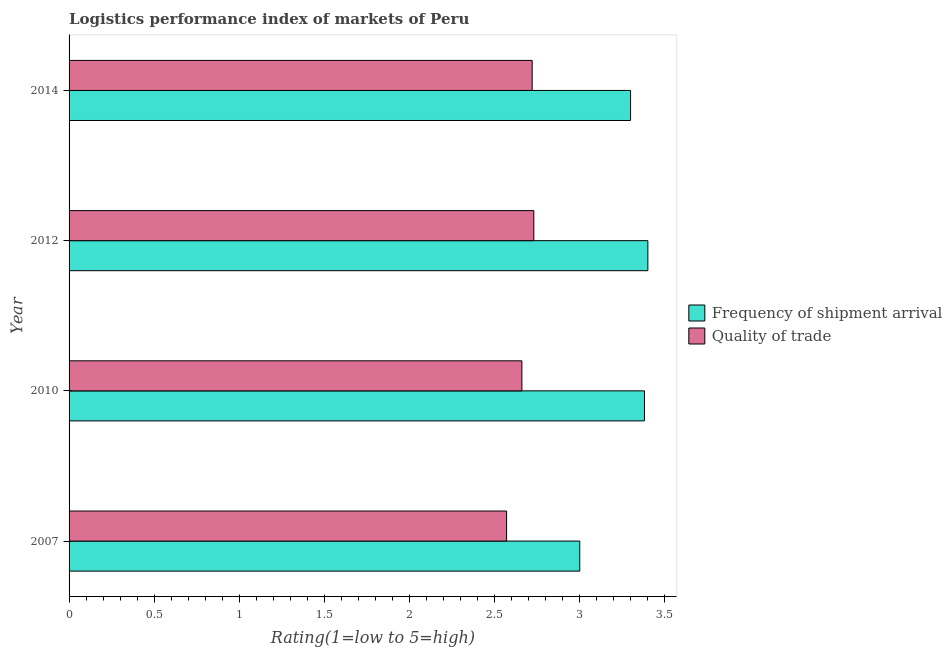What is the lpi quality of trade in 2007?
Provide a succinct answer. 2.57. What is the total lpi of frequency of shipment arrival in the graph?
Offer a terse response. 13.08. What is the difference between the lpi of frequency of shipment arrival in 2012 and that in 2014?
Provide a short and direct response. 0.1. What is the difference between the lpi of frequency of shipment arrival in 2010 and the lpi quality of trade in 2012?
Keep it short and to the point. 0.65. What is the average lpi of frequency of shipment arrival per year?
Your response must be concise. 3.27. In the year 2010, what is the difference between the lpi quality of trade and lpi of frequency of shipment arrival?
Make the answer very short. -0.72. In how many years, is the lpi quality of trade greater than 2.9 ?
Offer a terse response. 0. What is the ratio of the lpi of frequency of shipment arrival in 2007 to that in 2010?
Make the answer very short. 0.89. What is the difference between the highest and the lowest lpi of frequency of shipment arrival?
Your answer should be very brief. 0.4. In how many years, is the lpi of frequency of shipment arrival greater than the average lpi of frequency of shipment arrival taken over all years?
Offer a terse response. 3. What does the 2nd bar from the top in 2007 represents?
Your answer should be very brief. Frequency of shipment arrival. What does the 2nd bar from the bottom in 2010 represents?
Your answer should be compact. Quality of trade. How many bars are there?
Your response must be concise. 8. Are all the bars in the graph horizontal?
Make the answer very short. Yes. Does the graph contain any zero values?
Provide a short and direct response. No. Does the graph contain grids?
Your response must be concise. No. Where does the legend appear in the graph?
Provide a short and direct response. Center right. What is the title of the graph?
Ensure brevity in your answer.  Logistics performance index of markets of Peru. What is the label or title of the X-axis?
Offer a terse response. Rating(1=low to 5=high). What is the Rating(1=low to 5=high) of Frequency of shipment arrival in 2007?
Your answer should be very brief. 3. What is the Rating(1=low to 5=high) in Quality of trade in 2007?
Provide a succinct answer. 2.57. What is the Rating(1=low to 5=high) of Frequency of shipment arrival in 2010?
Your response must be concise. 3.38. What is the Rating(1=low to 5=high) of Quality of trade in 2010?
Offer a terse response. 2.66. What is the Rating(1=low to 5=high) of Frequency of shipment arrival in 2012?
Give a very brief answer. 3.4. What is the Rating(1=low to 5=high) of Quality of trade in 2012?
Give a very brief answer. 2.73. What is the Rating(1=low to 5=high) in Frequency of shipment arrival in 2014?
Ensure brevity in your answer.  3.3. What is the Rating(1=low to 5=high) in Quality of trade in 2014?
Give a very brief answer. 2.72. Across all years, what is the maximum Rating(1=low to 5=high) of Quality of trade?
Give a very brief answer. 2.73. Across all years, what is the minimum Rating(1=low to 5=high) of Frequency of shipment arrival?
Offer a very short reply. 3. Across all years, what is the minimum Rating(1=low to 5=high) of Quality of trade?
Ensure brevity in your answer.  2.57. What is the total Rating(1=low to 5=high) of Frequency of shipment arrival in the graph?
Your response must be concise. 13.08. What is the total Rating(1=low to 5=high) in Quality of trade in the graph?
Give a very brief answer. 10.68. What is the difference between the Rating(1=low to 5=high) of Frequency of shipment arrival in 2007 and that in 2010?
Provide a short and direct response. -0.38. What is the difference between the Rating(1=low to 5=high) of Quality of trade in 2007 and that in 2010?
Your response must be concise. -0.09. What is the difference between the Rating(1=low to 5=high) of Frequency of shipment arrival in 2007 and that in 2012?
Provide a short and direct response. -0.4. What is the difference between the Rating(1=low to 5=high) of Quality of trade in 2007 and that in 2012?
Offer a very short reply. -0.16. What is the difference between the Rating(1=low to 5=high) of Frequency of shipment arrival in 2007 and that in 2014?
Ensure brevity in your answer.  -0.3. What is the difference between the Rating(1=low to 5=high) in Quality of trade in 2007 and that in 2014?
Offer a terse response. -0.15. What is the difference between the Rating(1=low to 5=high) of Frequency of shipment arrival in 2010 and that in 2012?
Ensure brevity in your answer.  -0.02. What is the difference between the Rating(1=low to 5=high) in Quality of trade in 2010 and that in 2012?
Offer a very short reply. -0.07. What is the difference between the Rating(1=low to 5=high) in Frequency of shipment arrival in 2010 and that in 2014?
Provide a short and direct response. 0.08. What is the difference between the Rating(1=low to 5=high) of Quality of trade in 2010 and that in 2014?
Make the answer very short. -0.06. What is the difference between the Rating(1=low to 5=high) in Frequency of shipment arrival in 2012 and that in 2014?
Ensure brevity in your answer.  0.1. What is the difference between the Rating(1=low to 5=high) in Quality of trade in 2012 and that in 2014?
Provide a short and direct response. 0.01. What is the difference between the Rating(1=low to 5=high) in Frequency of shipment arrival in 2007 and the Rating(1=low to 5=high) in Quality of trade in 2010?
Your answer should be compact. 0.34. What is the difference between the Rating(1=low to 5=high) of Frequency of shipment arrival in 2007 and the Rating(1=low to 5=high) of Quality of trade in 2012?
Give a very brief answer. 0.27. What is the difference between the Rating(1=low to 5=high) in Frequency of shipment arrival in 2007 and the Rating(1=low to 5=high) in Quality of trade in 2014?
Your answer should be compact. 0.28. What is the difference between the Rating(1=low to 5=high) in Frequency of shipment arrival in 2010 and the Rating(1=low to 5=high) in Quality of trade in 2012?
Make the answer very short. 0.65. What is the difference between the Rating(1=low to 5=high) of Frequency of shipment arrival in 2010 and the Rating(1=low to 5=high) of Quality of trade in 2014?
Offer a very short reply. 0.66. What is the difference between the Rating(1=low to 5=high) of Frequency of shipment arrival in 2012 and the Rating(1=low to 5=high) of Quality of trade in 2014?
Offer a very short reply. 0.68. What is the average Rating(1=low to 5=high) of Frequency of shipment arrival per year?
Provide a short and direct response. 3.27. What is the average Rating(1=low to 5=high) in Quality of trade per year?
Give a very brief answer. 2.67. In the year 2007, what is the difference between the Rating(1=low to 5=high) in Frequency of shipment arrival and Rating(1=low to 5=high) in Quality of trade?
Your answer should be very brief. 0.43. In the year 2010, what is the difference between the Rating(1=low to 5=high) in Frequency of shipment arrival and Rating(1=low to 5=high) in Quality of trade?
Offer a very short reply. 0.72. In the year 2012, what is the difference between the Rating(1=low to 5=high) in Frequency of shipment arrival and Rating(1=low to 5=high) in Quality of trade?
Keep it short and to the point. 0.67. In the year 2014, what is the difference between the Rating(1=low to 5=high) in Frequency of shipment arrival and Rating(1=low to 5=high) in Quality of trade?
Your response must be concise. 0.58. What is the ratio of the Rating(1=low to 5=high) of Frequency of shipment arrival in 2007 to that in 2010?
Keep it short and to the point. 0.89. What is the ratio of the Rating(1=low to 5=high) of Quality of trade in 2007 to that in 2010?
Offer a terse response. 0.97. What is the ratio of the Rating(1=low to 5=high) in Frequency of shipment arrival in 2007 to that in 2012?
Your response must be concise. 0.88. What is the ratio of the Rating(1=low to 5=high) of Quality of trade in 2007 to that in 2012?
Your answer should be compact. 0.94. What is the ratio of the Rating(1=low to 5=high) of Frequency of shipment arrival in 2007 to that in 2014?
Offer a terse response. 0.91. What is the ratio of the Rating(1=low to 5=high) of Quality of trade in 2007 to that in 2014?
Offer a terse response. 0.94. What is the ratio of the Rating(1=low to 5=high) of Quality of trade in 2010 to that in 2012?
Offer a terse response. 0.97. What is the ratio of the Rating(1=low to 5=high) in Frequency of shipment arrival in 2010 to that in 2014?
Your answer should be compact. 1.02. What is the ratio of the Rating(1=low to 5=high) of Quality of trade in 2010 to that in 2014?
Offer a terse response. 0.98. What is the ratio of the Rating(1=low to 5=high) of Frequency of shipment arrival in 2012 to that in 2014?
Provide a succinct answer. 1.03. What is the difference between the highest and the second highest Rating(1=low to 5=high) in Quality of trade?
Your response must be concise. 0.01. What is the difference between the highest and the lowest Rating(1=low to 5=high) of Quality of trade?
Keep it short and to the point. 0.16. 